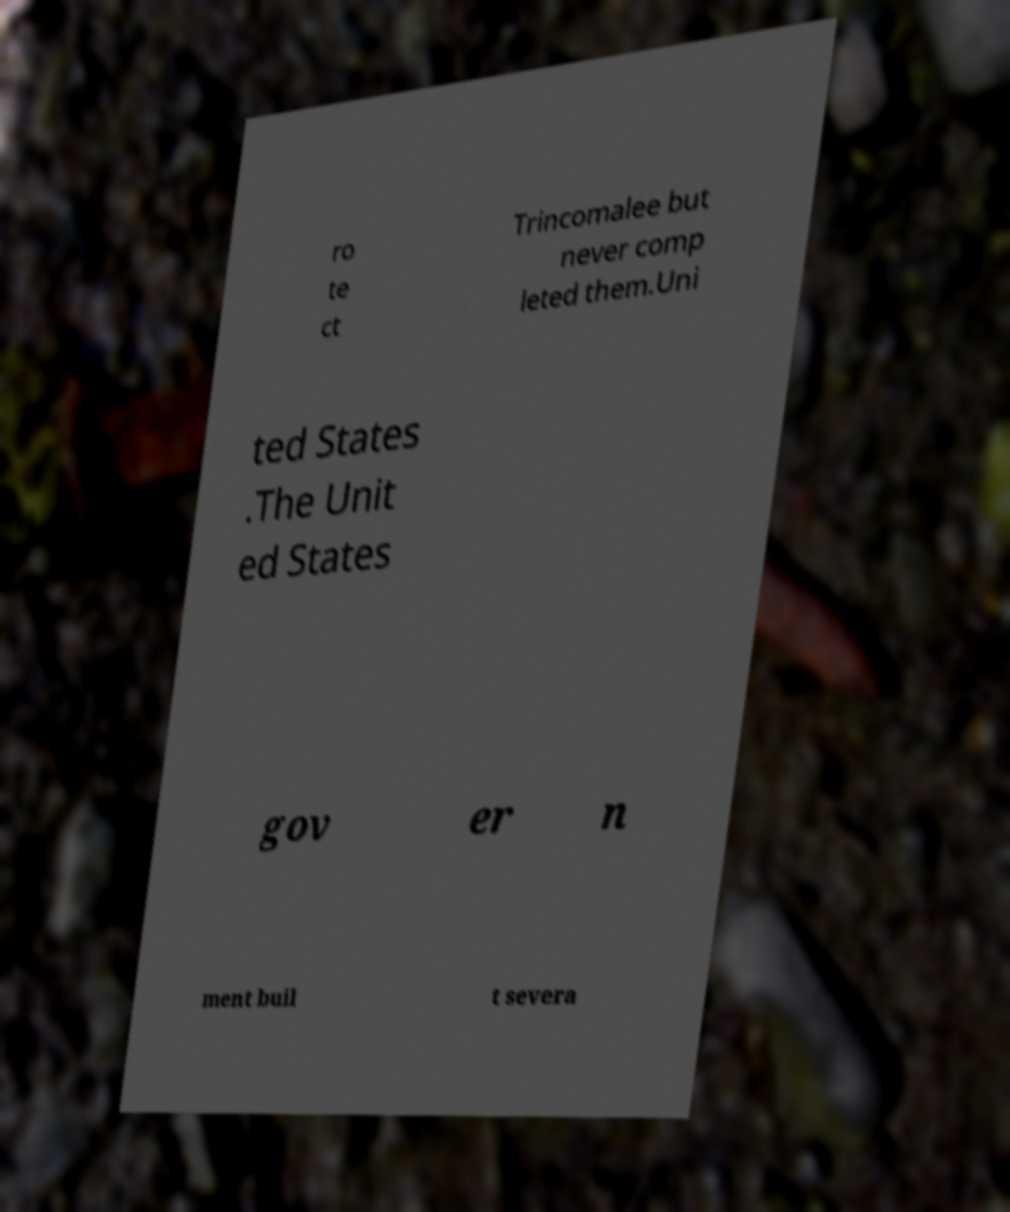For documentation purposes, I need the text within this image transcribed. Could you provide that? ro te ct Trincomalee but never comp leted them.Uni ted States .The Unit ed States gov er n ment buil t severa 